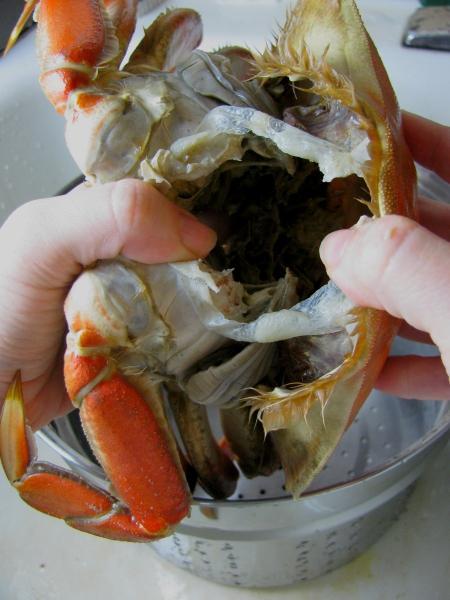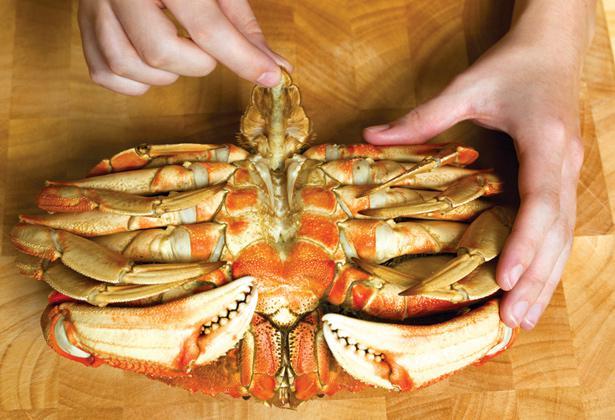The first image is the image on the left, the second image is the image on the right. Examine the images to the left and right. Is the description "A person is holding up the crab in the image on the left." accurate? Answer yes or no. Yes. The first image is the image on the left, the second image is the image on the right. Examine the images to the left and right. Is the description "A hand is holding onto a crab in at least one image, and a crab is on a wooden board in the right image." accurate? Answer yes or no. Yes. 